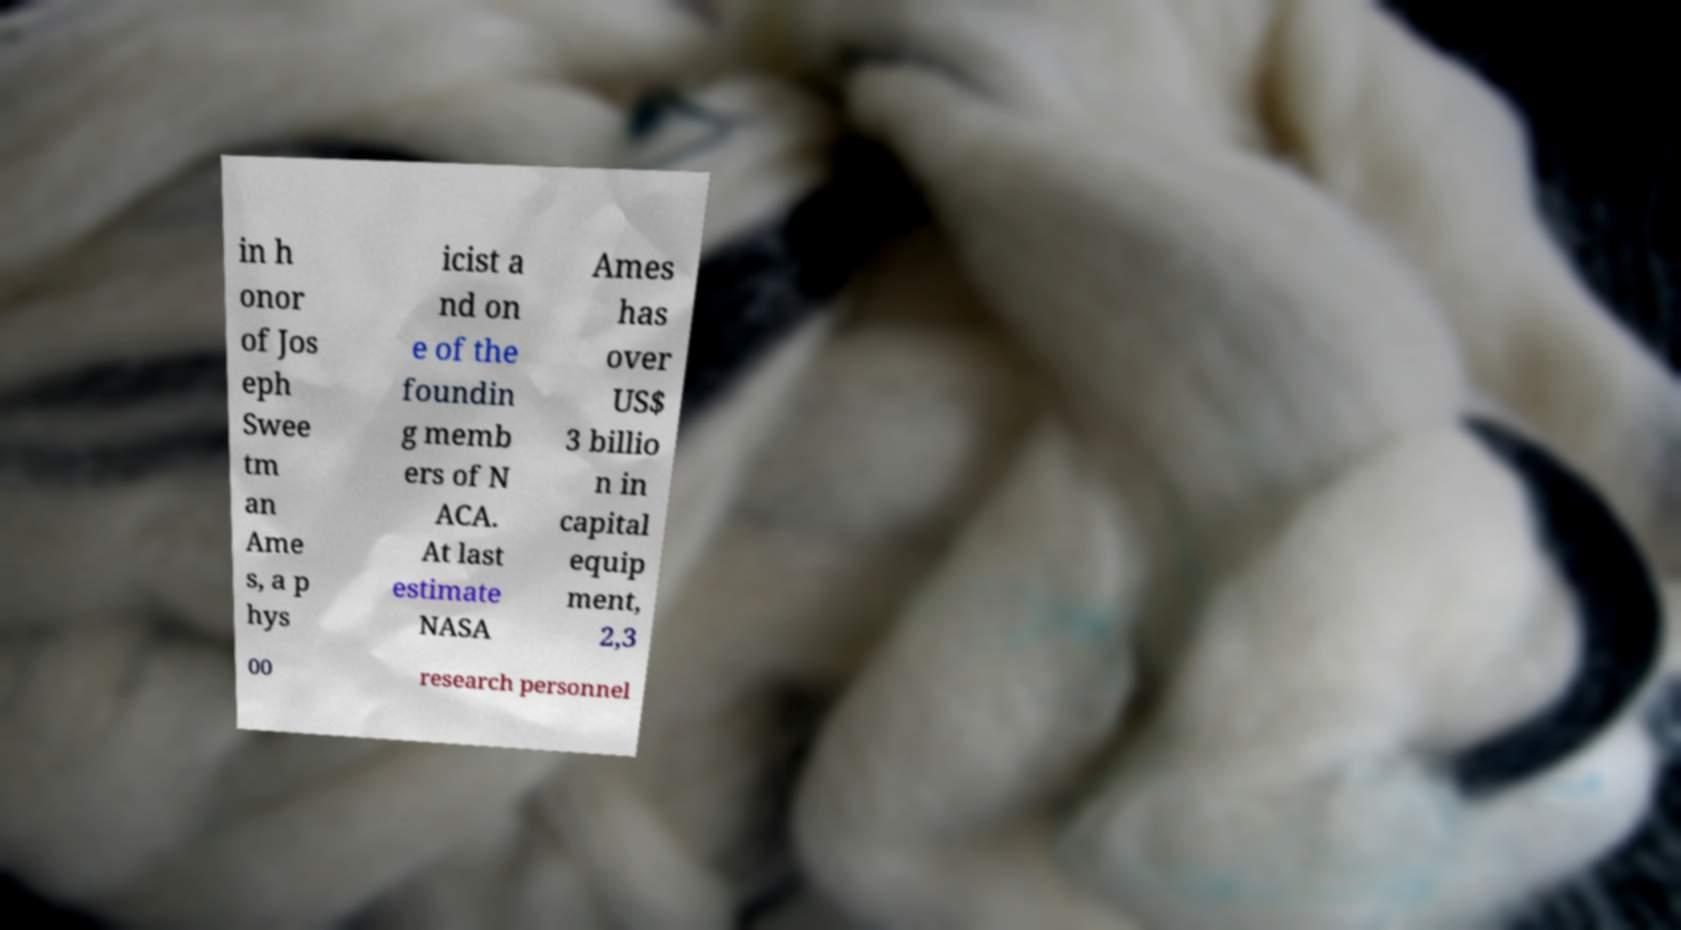Please read and relay the text visible in this image. What does it say? in h onor of Jos eph Swee tm an Ame s, a p hys icist a nd on e of the foundin g memb ers of N ACA. At last estimate NASA Ames has over US$ 3 billio n in capital equip ment, 2,3 00 research personnel 